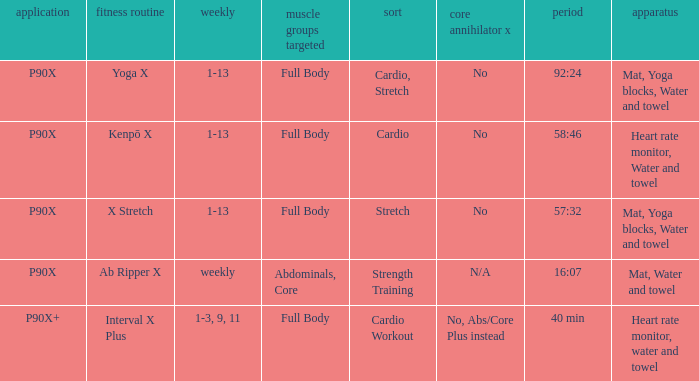Parse the table in full. {'header': ['application', 'fitness routine', 'weekly', 'muscle groups targeted', 'sort', 'core annihilator x', 'period', 'apparatus'], 'rows': [['P90X', 'Yoga X', '1-13', 'Full Body', 'Cardio, Stretch', 'No', '92:24', 'Mat, Yoga blocks, Water and towel'], ['P90X', 'Kenpō X', '1-13', 'Full Body', 'Cardio', 'No', '58:46', 'Heart rate monitor, Water and towel'], ['P90X', 'X Stretch', '1-13', 'Full Body', 'Stretch', 'No', '57:32', 'Mat, Yoga blocks, Water and towel'], ['P90X', 'Ab Ripper X', 'weekly', 'Abdominals, Core', 'Strength Training', 'N/A', '16:07', 'Mat, Water and towel'], ['P90X+', 'Interval X Plus', '1-3, 9, 11', 'Full Body', 'Cardio Workout', 'No, Abs/Core Plus instead', '40 min', 'Heart rate monitor, water and towel']]} What is the ab ripper x when exercise is x stretch? No. 